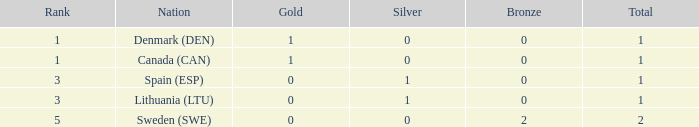If the total medals exceed 1 and at least one gold medal is present, what is the quantity of bronze medals won? None. 